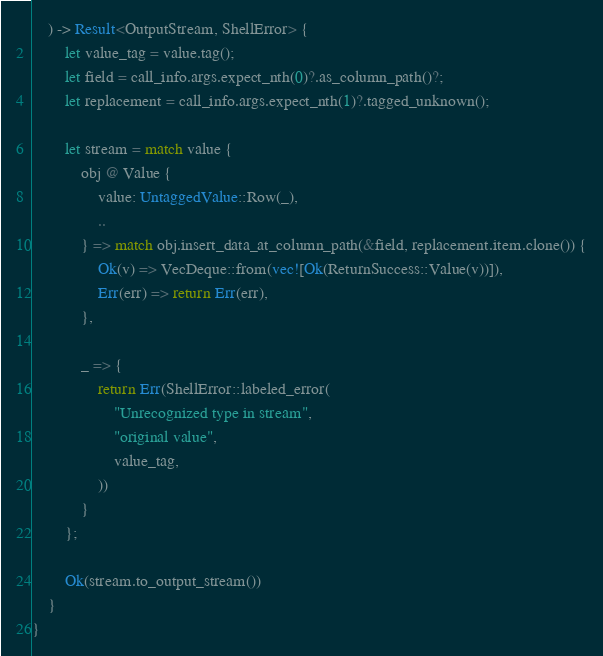<code> <loc_0><loc_0><loc_500><loc_500><_Rust_>    ) -> Result<OutputStream, ShellError> {
        let value_tag = value.tag();
        let field = call_info.args.expect_nth(0)?.as_column_path()?;
        let replacement = call_info.args.expect_nth(1)?.tagged_unknown();

        let stream = match value {
            obj @ Value {
                value: UntaggedValue::Row(_),
                ..
            } => match obj.insert_data_at_column_path(&field, replacement.item.clone()) {
                Ok(v) => VecDeque::from(vec![Ok(ReturnSuccess::Value(v))]),
                Err(err) => return Err(err),
            },

            _ => {
                return Err(ShellError::labeled_error(
                    "Unrecognized type in stream",
                    "original value",
                    value_tag,
                ))
            }
        };

        Ok(stream.to_output_stream())
    }
}
</code> 